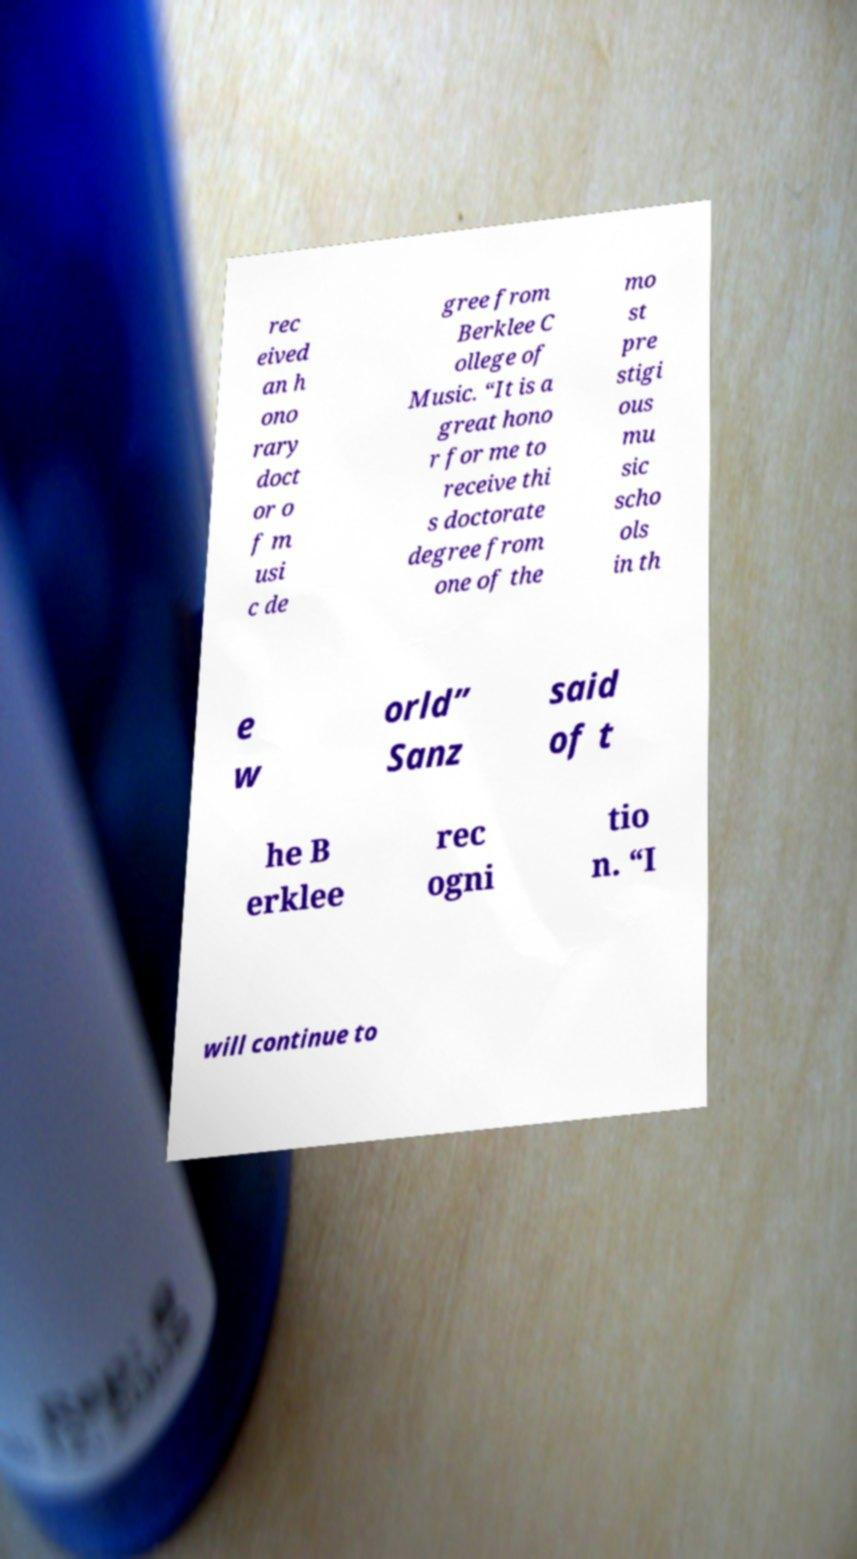What messages or text are displayed in this image? I need them in a readable, typed format. rec eived an h ono rary doct or o f m usi c de gree from Berklee C ollege of Music. “It is a great hono r for me to receive thi s doctorate degree from one of the mo st pre stigi ous mu sic scho ols in th e w orld” Sanz said of t he B erklee rec ogni tio n. “I will continue to 